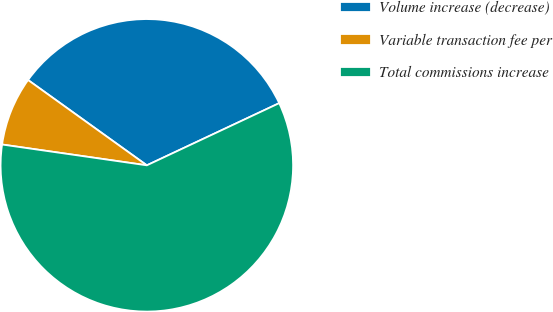Convert chart to OTSL. <chart><loc_0><loc_0><loc_500><loc_500><pie_chart><fcel>Volume increase (decrease)<fcel>Variable transaction fee per<fcel>Total commissions increase<nl><fcel>33.1%<fcel>7.64%<fcel>59.26%<nl></chart> 